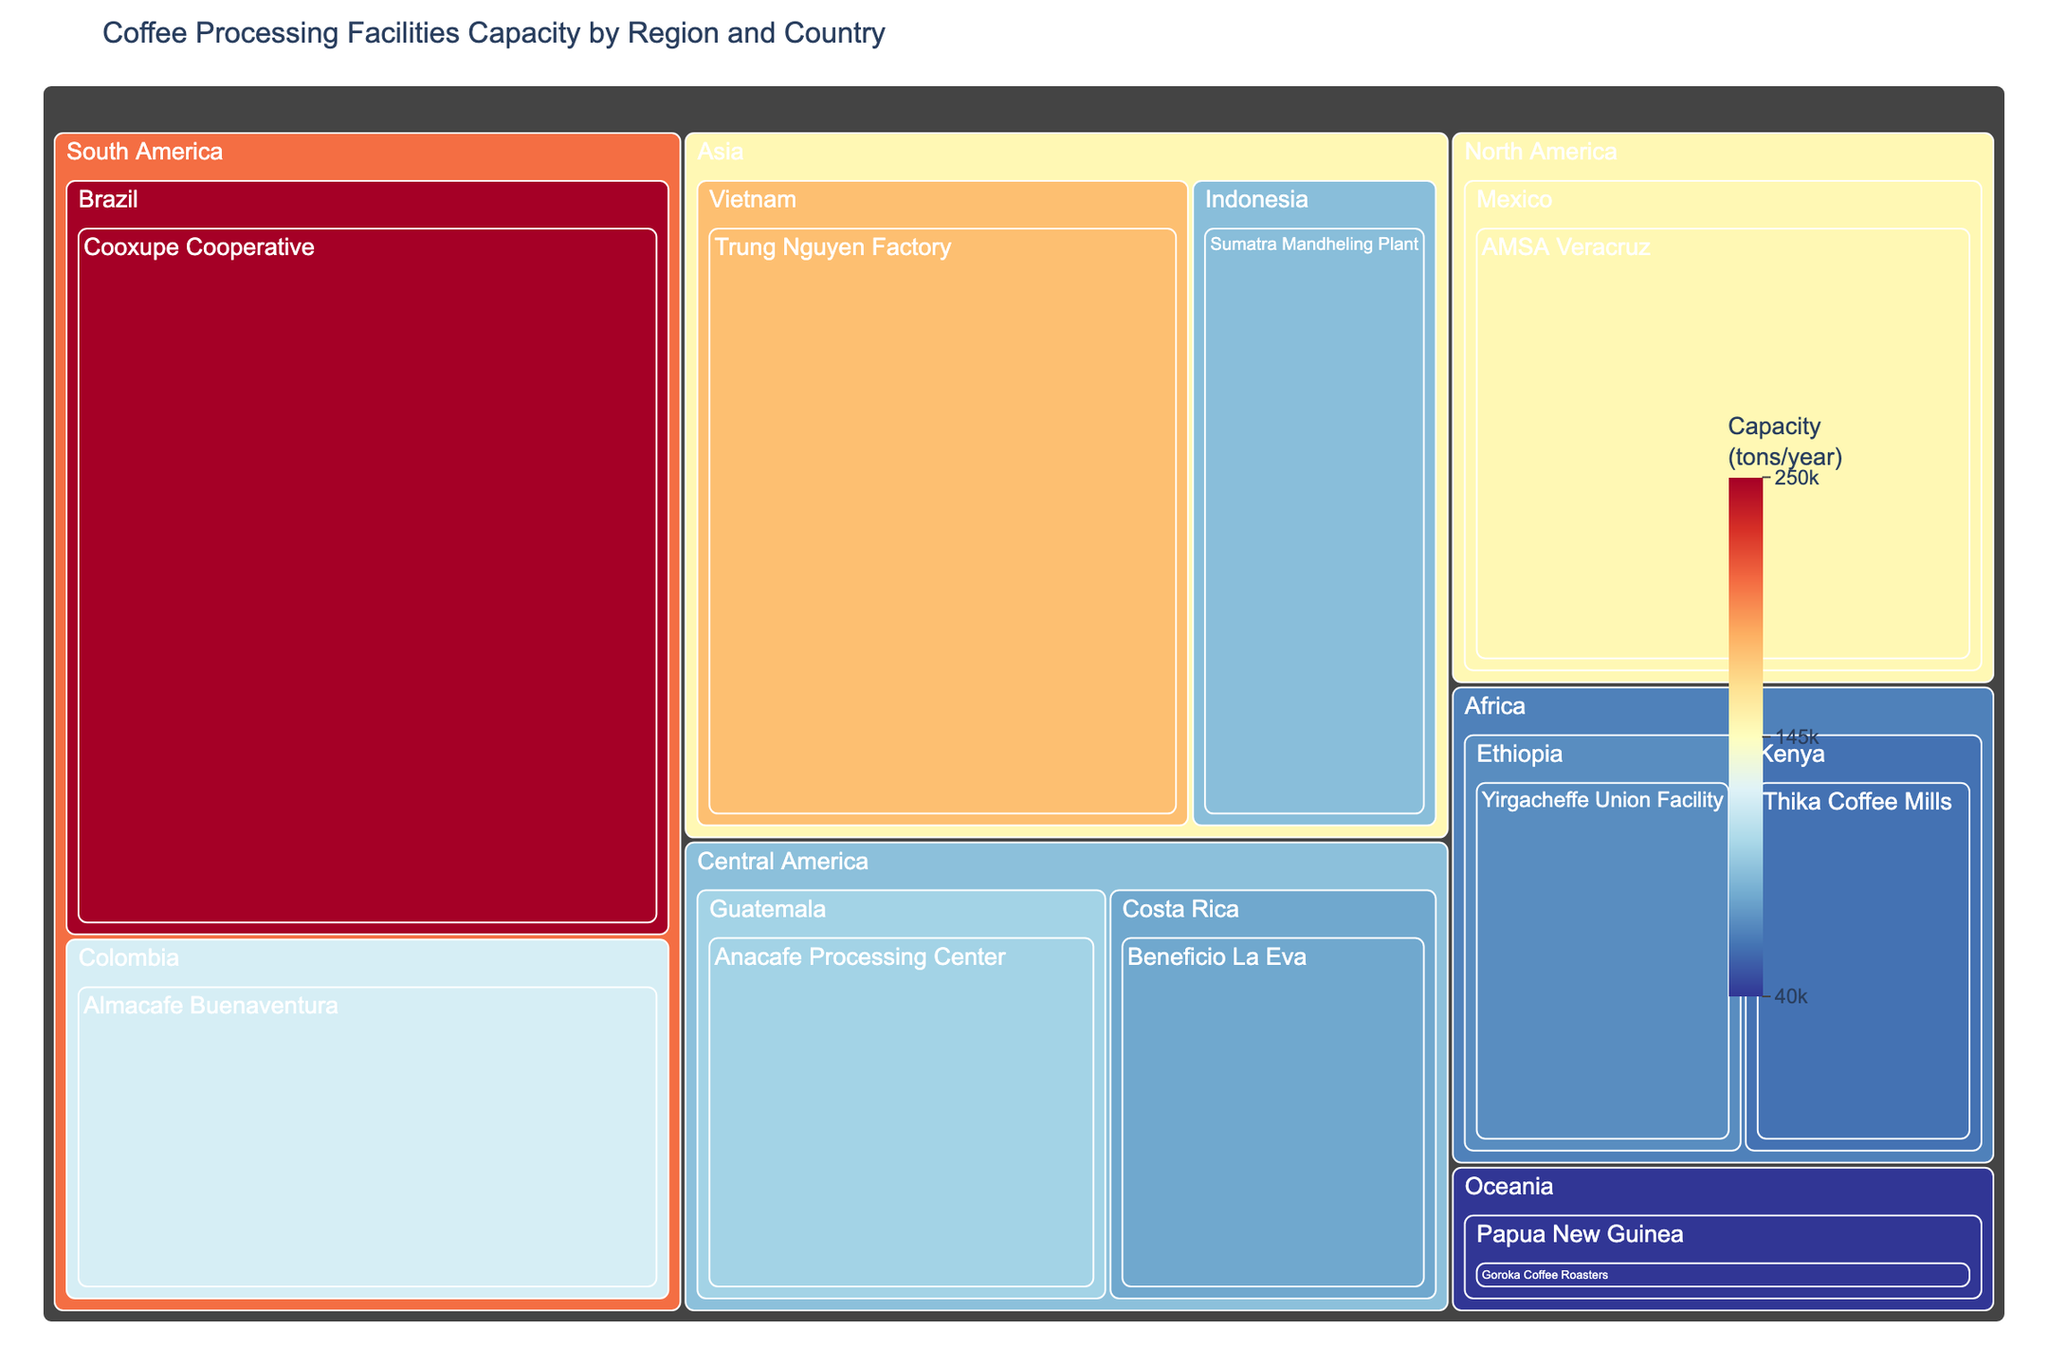Which region has the highest coffee processing capacity? By looking at the size of the regions in the treemap and observing their capacities, South America stands out as the region with the highest coffee processing capacity due to Brazil's Cooxupe Cooperative alone contributing 250,000 tons/year.
Answer: South America What is the capacity of the Trung Nguyen Factory in Vietnam? Locate the section labeled "Vietnam" under the "Asia" region and then find the Trung Nguyen Factory. The capacity displayed is 180,000 tons/year.
Answer: 180,000 tons/year Which coffee processing facility in Africa has the highest capacity? Identify the regions categorized under Africa and compare the capacities of the facilities. The Yirgacheffe Union Facility in Ethiopia with 70,000 tons/year is the one with the highest capacity.
Answer: Yirgacheffe Union Facility How does the capacity of AMSA Veracruz in Mexico compare to Almacafe Buenaventura in Colombia? Locate both facilities on the treemap. AMSA Veracruz (North America, Mexico) has a capacity of 150,000 tons/year, while Almacafe Buenaventura (South America, Colombia) has 120,000 tons/year. Thus, AMSA Veracruz has a higher capacity.
Answer: AMSA Veracruz has a higher capacity What is the total coffee processing capacity for the Central America region? Add up the capacities of the facilities in Central America: Beneficio La Eva in Costa Rica (80,000 tons/year) and Anacafe Processing Center in Guatemala (100,000 tons/year). The sum is 80,000 + 100,000 = 180,000 tons/year.
Answer: 180,000 tons/year What's the difference in capacity between the largest and smallest facilities? Identify the largest facility (Cooxupe Cooperative in Brazil with 250,000 tons/year) and the smallest facility (Goroka Coffee Roasters in Papua New Guinea with 40,000 tons/year). Calculate the difference: 250,000 - 40,000 = 210,000 tons/year.
Answer: 210,000 tons/year How many facilities have a capacity greater than 100,000 tons/year? Identify and count the facilities with capacities exceeding 100,000 tons/year: Cooxupe Cooperative (250,000), Trung Nguyen Factory (180,000), AMSA Veracruz (150,000), and Almacafe Buenaventura (120,000). There are four such facilities.
Answer: 4 facilities What is the average capacity of the facilities in the Asia region? There are two facilities in the Asia region: Trung Nguyen Factory (180,000 tons/year) and Sumatra Mandheling Plant (90,000 tons/year). Calculate the average: (180,000 + 90,000) / 2 = 135,000 tons/year.
Answer: 135,000 tons/year 